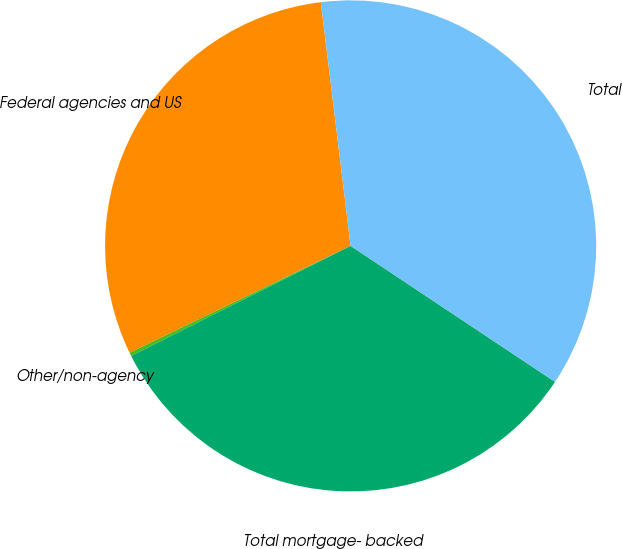<chart> <loc_0><loc_0><loc_500><loc_500><pie_chart><fcel>Federal agencies and US<fcel>Other/non-agency<fcel>Total mortgage- backed<fcel>Total<nl><fcel>30.23%<fcel>0.23%<fcel>33.26%<fcel>36.28%<nl></chart> 